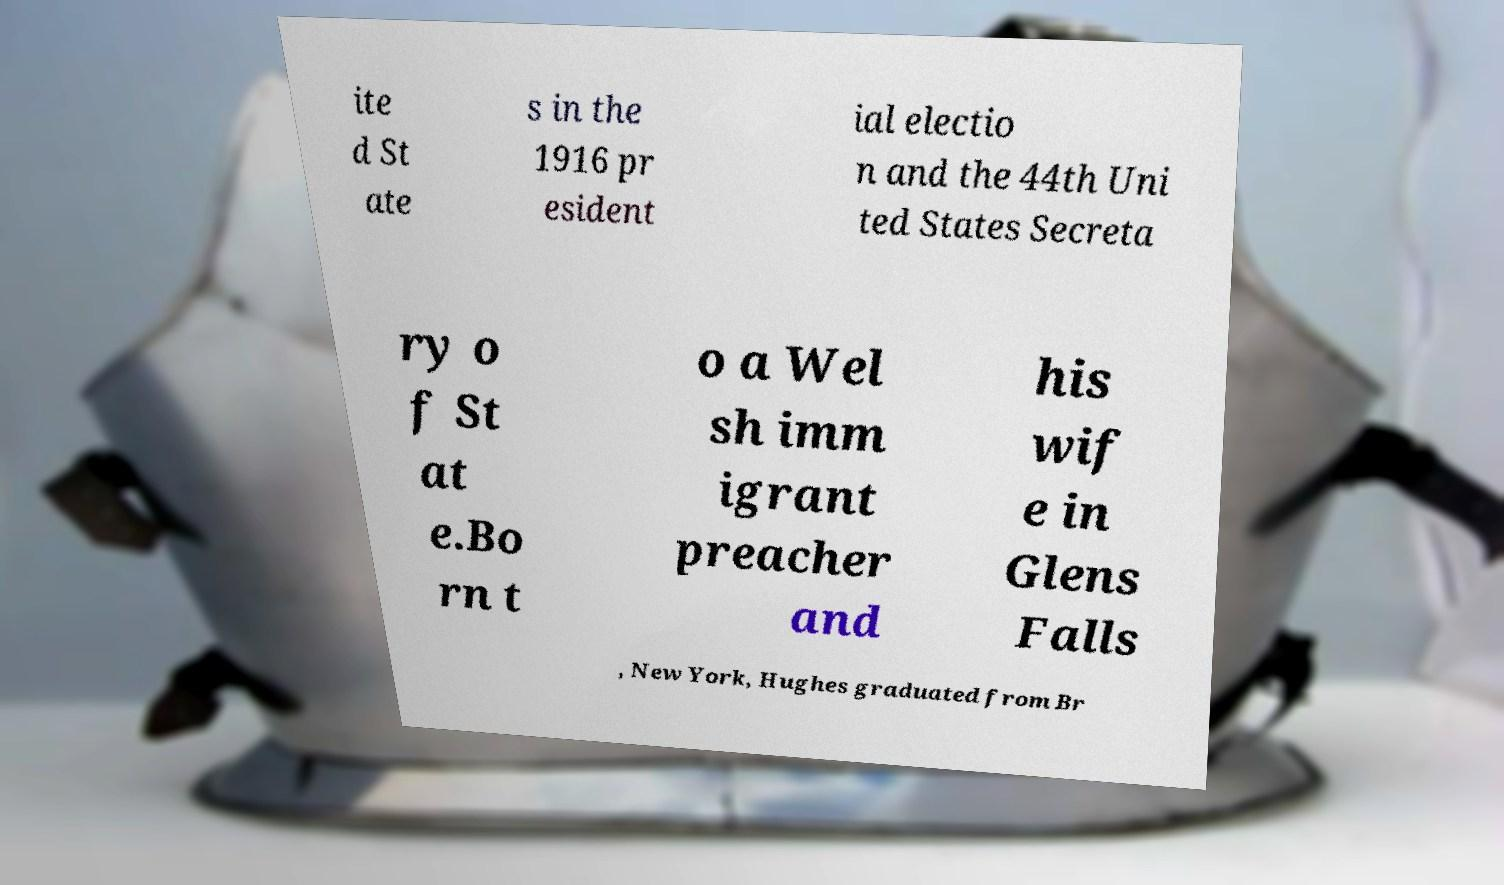Can you accurately transcribe the text from the provided image for me? ite d St ate s in the 1916 pr esident ial electio n and the 44th Uni ted States Secreta ry o f St at e.Bo rn t o a Wel sh imm igrant preacher and his wif e in Glens Falls , New York, Hughes graduated from Br 